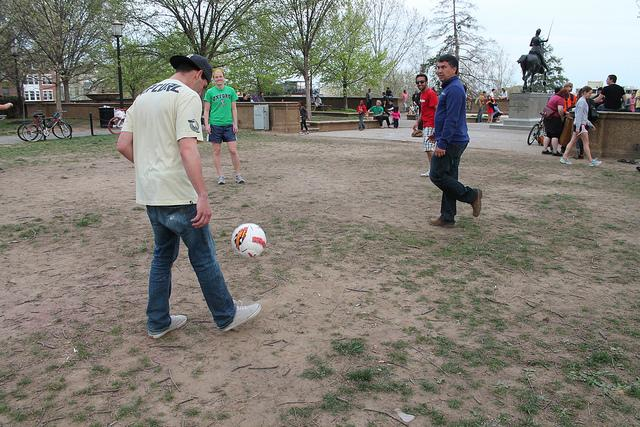What sport other that the ball's proper sport does the ball look closest to belonging to?

Choices:
A) american football
B) volleyball
C) golf
D) tennis volleyball 